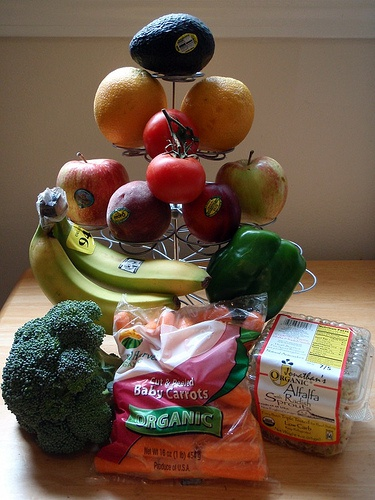Describe the objects in this image and their specific colors. I can see dining table in gray, maroon, white, and tan tones, broccoli in gray, black, and teal tones, banana in gray, olive, black, and beige tones, orange in gray, maroon, brown, and ivory tones, and carrot in gray, maroon, brown, and black tones in this image. 